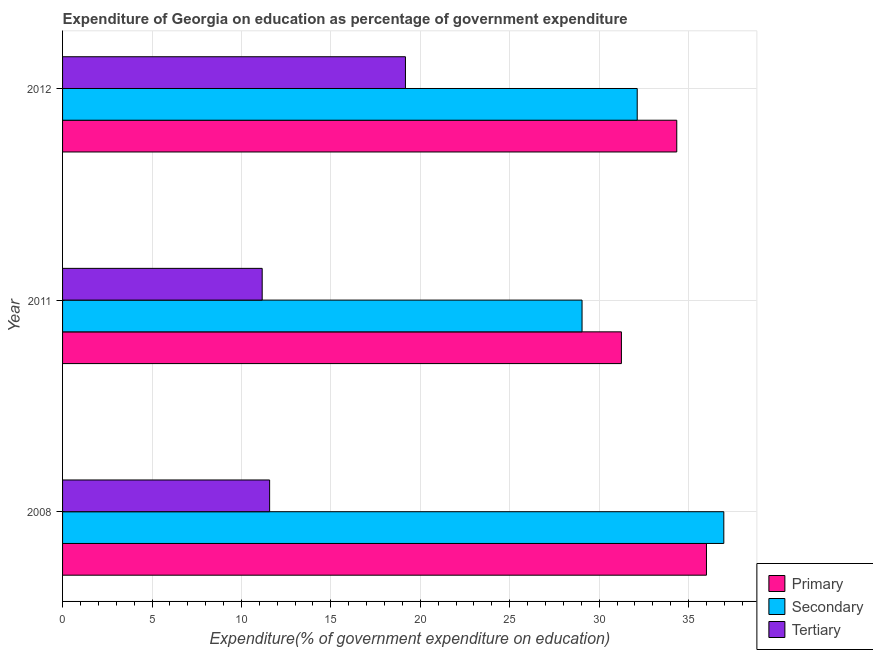How many different coloured bars are there?
Provide a short and direct response. 3. How many groups of bars are there?
Your response must be concise. 3. Are the number of bars per tick equal to the number of legend labels?
Ensure brevity in your answer.  Yes. Are the number of bars on each tick of the Y-axis equal?
Make the answer very short. Yes. How many bars are there on the 2nd tick from the top?
Give a very brief answer. 3. How many bars are there on the 1st tick from the bottom?
Your answer should be very brief. 3. What is the label of the 1st group of bars from the top?
Offer a very short reply. 2012. What is the expenditure on tertiary education in 2012?
Keep it short and to the point. 19.17. Across all years, what is the maximum expenditure on secondary education?
Keep it short and to the point. 36.97. Across all years, what is the minimum expenditure on tertiary education?
Offer a terse response. 11.16. In which year was the expenditure on tertiary education minimum?
Your response must be concise. 2011. What is the total expenditure on tertiary education in the graph?
Provide a short and direct response. 41.91. What is the difference between the expenditure on primary education in 2008 and that in 2011?
Your response must be concise. 4.75. What is the difference between the expenditure on secondary education in 2008 and the expenditure on tertiary education in 2011?
Your answer should be very brief. 25.81. What is the average expenditure on secondary education per year?
Ensure brevity in your answer.  32.71. In the year 2008, what is the difference between the expenditure on primary education and expenditure on tertiary education?
Keep it short and to the point. 24.42. In how many years, is the expenditure on primary education greater than 3 %?
Offer a very short reply. 3. What is the ratio of the expenditure on secondary education in 2011 to that in 2012?
Your response must be concise. 0.9. Is the expenditure on tertiary education in 2011 less than that in 2012?
Provide a succinct answer. Yes. What is the difference between the highest and the second highest expenditure on primary education?
Provide a short and direct response. 1.66. What is the difference between the highest and the lowest expenditure on secondary education?
Give a very brief answer. 7.93. What does the 2nd bar from the top in 2008 represents?
Give a very brief answer. Secondary. What does the 3rd bar from the bottom in 2008 represents?
Make the answer very short. Tertiary. Is it the case that in every year, the sum of the expenditure on primary education and expenditure on secondary education is greater than the expenditure on tertiary education?
Provide a short and direct response. Yes. Are all the bars in the graph horizontal?
Your answer should be compact. Yes. How many years are there in the graph?
Keep it short and to the point. 3. Are the values on the major ticks of X-axis written in scientific E-notation?
Ensure brevity in your answer.  No. Does the graph contain any zero values?
Provide a succinct answer. No. What is the title of the graph?
Give a very brief answer. Expenditure of Georgia on education as percentage of government expenditure. What is the label or title of the X-axis?
Offer a very short reply. Expenditure(% of government expenditure on education). What is the Expenditure(% of government expenditure on education) of Primary in 2008?
Your answer should be compact. 36. What is the Expenditure(% of government expenditure on education) in Secondary in 2008?
Provide a short and direct response. 36.97. What is the Expenditure(% of government expenditure on education) of Tertiary in 2008?
Keep it short and to the point. 11.58. What is the Expenditure(% of government expenditure on education) of Primary in 2011?
Ensure brevity in your answer.  31.24. What is the Expenditure(% of government expenditure on education) in Secondary in 2011?
Provide a succinct answer. 29.04. What is the Expenditure(% of government expenditure on education) in Tertiary in 2011?
Offer a terse response. 11.16. What is the Expenditure(% of government expenditure on education) in Primary in 2012?
Your response must be concise. 34.34. What is the Expenditure(% of government expenditure on education) of Secondary in 2012?
Provide a succinct answer. 32.13. What is the Expenditure(% of government expenditure on education) in Tertiary in 2012?
Provide a succinct answer. 19.17. Across all years, what is the maximum Expenditure(% of government expenditure on education) of Primary?
Offer a terse response. 36. Across all years, what is the maximum Expenditure(% of government expenditure on education) of Secondary?
Your answer should be compact. 36.97. Across all years, what is the maximum Expenditure(% of government expenditure on education) in Tertiary?
Offer a terse response. 19.17. Across all years, what is the minimum Expenditure(% of government expenditure on education) in Primary?
Your answer should be compact. 31.24. Across all years, what is the minimum Expenditure(% of government expenditure on education) of Secondary?
Your answer should be compact. 29.04. Across all years, what is the minimum Expenditure(% of government expenditure on education) of Tertiary?
Ensure brevity in your answer.  11.16. What is the total Expenditure(% of government expenditure on education) of Primary in the graph?
Offer a terse response. 101.58. What is the total Expenditure(% of government expenditure on education) in Secondary in the graph?
Offer a very short reply. 98.14. What is the total Expenditure(% of government expenditure on education) of Tertiary in the graph?
Give a very brief answer. 41.91. What is the difference between the Expenditure(% of government expenditure on education) of Primary in 2008 and that in 2011?
Offer a terse response. 4.75. What is the difference between the Expenditure(% of government expenditure on education) in Secondary in 2008 and that in 2011?
Provide a succinct answer. 7.93. What is the difference between the Expenditure(% of government expenditure on education) of Tertiary in 2008 and that in 2011?
Offer a terse response. 0.42. What is the difference between the Expenditure(% of government expenditure on education) in Primary in 2008 and that in 2012?
Your response must be concise. 1.66. What is the difference between the Expenditure(% of government expenditure on education) of Secondary in 2008 and that in 2012?
Offer a terse response. 4.84. What is the difference between the Expenditure(% of government expenditure on education) in Tertiary in 2008 and that in 2012?
Your answer should be compact. -7.59. What is the difference between the Expenditure(% of government expenditure on education) in Primary in 2011 and that in 2012?
Provide a short and direct response. -3.09. What is the difference between the Expenditure(% of government expenditure on education) in Secondary in 2011 and that in 2012?
Offer a very short reply. -3.08. What is the difference between the Expenditure(% of government expenditure on education) in Tertiary in 2011 and that in 2012?
Provide a succinct answer. -8.01. What is the difference between the Expenditure(% of government expenditure on education) of Primary in 2008 and the Expenditure(% of government expenditure on education) of Secondary in 2011?
Your answer should be compact. 6.96. What is the difference between the Expenditure(% of government expenditure on education) of Primary in 2008 and the Expenditure(% of government expenditure on education) of Tertiary in 2011?
Your answer should be compact. 24.84. What is the difference between the Expenditure(% of government expenditure on education) in Secondary in 2008 and the Expenditure(% of government expenditure on education) in Tertiary in 2011?
Your answer should be compact. 25.81. What is the difference between the Expenditure(% of government expenditure on education) of Primary in 2008 and the Expenditure(% of government expenditure on education) of Secondary in 2012?
Your answer should be compact. 3.87. What is the difference between the Expenditure(% of government expenditure on education) in Primary in 2008 and the Expenditure(% of government expenditure on education) in Tertiary in 2012?
Ensure brevity in your answer.  16.83. What is the difference between the Expenditure(% of government expenditure on education) in Secondary in 2008 and the Expenditure(% of government expenditure on education) in Tertiary in 2012?
Your answer should be very brief. 17.8. What is the difference between the Expenditure(% of government expenditure on education) of Primary in 2011 and the Expenditure(% of government expenditure on education) of Secondary in 2012?
Provide a succinct answer. -0.88. What is the difference between the Expenditure(% of government expenditure on education) in Primary in 2011 and the Expenditure(% of government expenditure on education) in Tertiary in 2012?
Provide a succinct answer. 12.07. What is the difference between the Expenditure(% of government expenditure on education) of Secondary in 2011 and the Expenditure(% of government expenditure on education) of Tertiary in 2012?
Provide a succinct answer. 9.87. What is the average Expenditure(% of government expenditure on education) of Primary per year?
Offer a very short reply. 33.86. What is the average Expenditure(% of government expenditure on education) in Secondary per year?
Offer a very short reply. 32.71. What is the average Expenditure(% of government expenditure on education) of Tertiary per year?
Keep it short and to the point. 13.97. In the year 2008, what is the difference between the Expenditure(% of government expenditure on education) of Primary and Expenditure(% of government expenditure on education) of Secondary?
Offer a very short reply. -0.97. In the year 2008, what is the difference between the Expenditure(% of government expenditure on education) of Primary and Expenditure(% of government expenditure on education) of Tertiary?
Keep it short and to the point. 24.42. In the year 2008, what is the difference between the Expenditure(% of government expenditure on education) of Secondary and Expenditure(% of government expenditure on education) of Tertiary?
Make the answer very short. 25.39. In the year 2011, what is the difference between the Expenditure(% of government expenditure on education) of Primary and Expenditure(% of government expenditure on education) of Secondary?
Make the answer very short. 2.2. In the year 2011, what is the difference between the Expenditure(% of government expenditure on education) of Primary and Expenditure(% of government expenditure on education) of Tertiary?
Offer a terse response. 20.08. In the year 2011, what is the difference between the Expenditure(% of government expenditure on education) in Secondary and Expenditure(% of government expenditure on education) in Tertiary?
Ensure brevity in your answer.  17.88. In the year 2012, what is the difference between the Expenditure(% of government expenditure on education) in Primary and Expenditure(% of government expenditure on education) in Secondary?
Your response must be concise. 2.21. In the year 2012, what is the difference between the Expenditure(% of government expenditure on education) in Primary and Expenditure(% of government expenditure on education) in Tertiary?
Provide a short and direct response. 15.17. In the year 2012, what is the difference between the Expenditure(% of government expenditure on education) of Secondary and Expenditure(% of government expenditure on education) of Tertiary?
Give a very brief answer. 12.96. What is the ratio of the Expenditure(% of government expenditure on education) of Primary in 2008 to that in 2011?
Keep it short and to the point. 1.15. What is the ratio of the Expenditure(% of government expenditure on education) in Secondary in 2008 to that in 2011?
Ensure brevity in your answer.  1.27. What is the ratio of the Expenditure(% of government expenditure on education) in Tertiary in 2008 to that in 2011?
Offer a very short reply. 1.04. What is the ratio of the Expenditure(% of government expenditure on education) of Primary in 2008 to that in 2012?
Offer a terse response. 1.05. What is the ratio of the Expenditure(% of government expenditure on education) of Secondary in 2008 to that in 2012?
Offer a very short reply. 1.15. What is the ratio of the Expenditure(% of government expenditure on education) of Tertiary in 2008 to that in 2012?
Make the answer very short. 0.6. What is the ratio of the Expenditure(% of government expenditure on education) in Primary in 2011 to that in 2012?
Your response must be concise. 0.91. What is the ratio of the Expenditure(% of government expenditure on education) of Secondary in 2011 to that in 2012?
Provide a succinct answer. 0.9. What is the ratio of the Expenditure(% of government expenditure on education) in Tertiary in 2011 to that in 2012?
Provide a short and direct response. 0.58. What is the difference between the highest and the second highest Expenditure(% of government expenditure on education) of Primary?
Give a very brief answer. 1.66. What is the difference between the highest and the second highest Expenditure(% of government expenditure on education) in Secondary?
Your answer should be very brief. 4.84. What is the difference between the highest and the second highest Expenditure(% of government expenditure on education) of Tertiary?
Provide a succinct answer. 7.59. What is the difference between the highest and the lowest Expenditure(% of government expenditure on education) in Primary?
Provide a succinct answer. 4.75. What is the difference between the highest and the lowest Expenditure(% of government expenditure on education) of Secondary?
Give a very brief answer. 7.93. What is the difference between the highest and the lowest Expenditure(% of government expenditure on education) of Tertiary?
Ensure brevity in your answer.  8.01. 